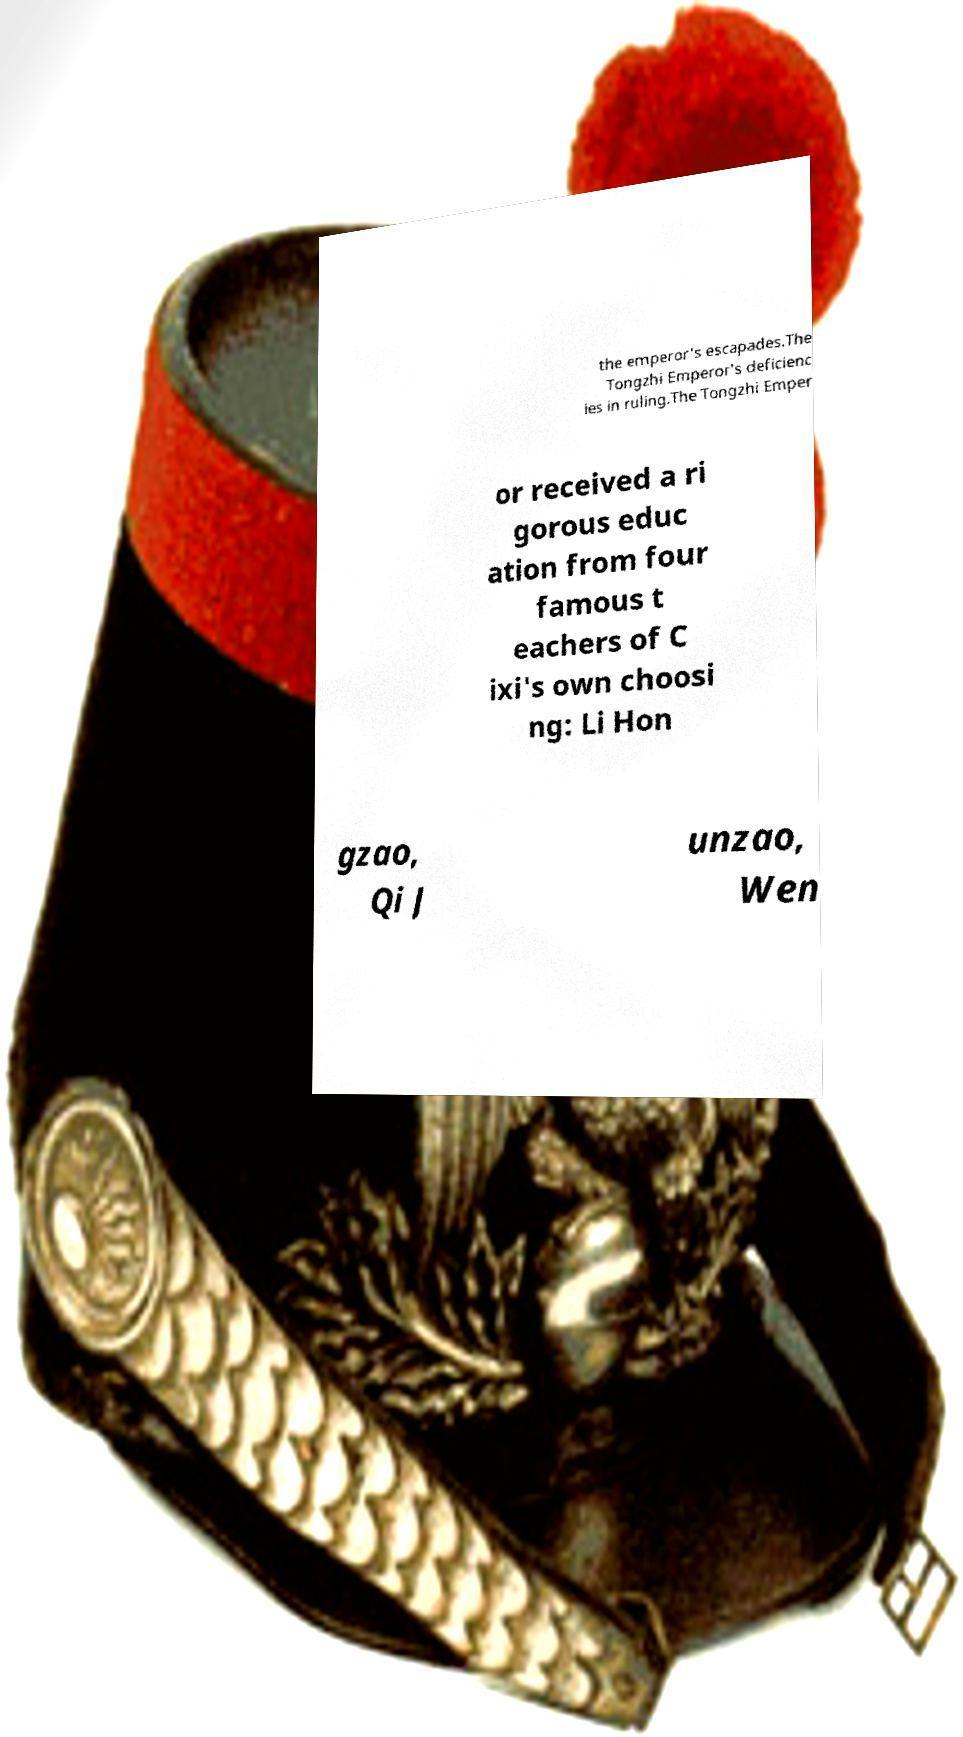What messages or text are displayed in this image? I need them in a readable, typed format. the emperor's escapades.The Tongzhi Emperor's deficienc ies in ruling.The Tongzhi Emper or received a ri gorous educ ation from four famous t eachers of C ixi's own choosi ng: Li Hon gzao, Qi J unzao, Wen 